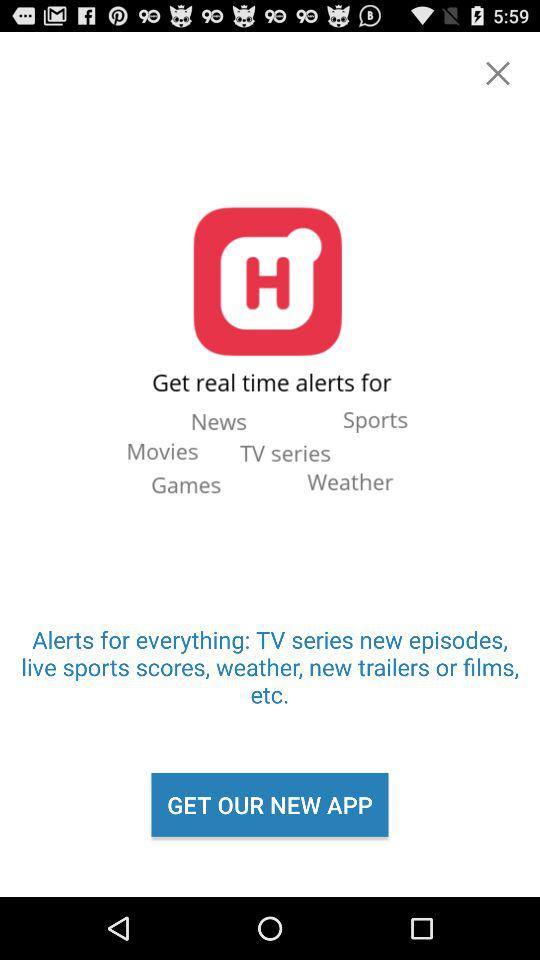What kind of alerts do we get from this app? The alerts are "News", "Sports", "Movies", "TV Series", "Games", and "Weather". 